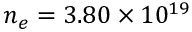<formula> <loc_0><loc_0><loc_500><loc_500>n _ { e } = 3 . 8 0 \times 1 0 ^ { 1 9 }</formula> 